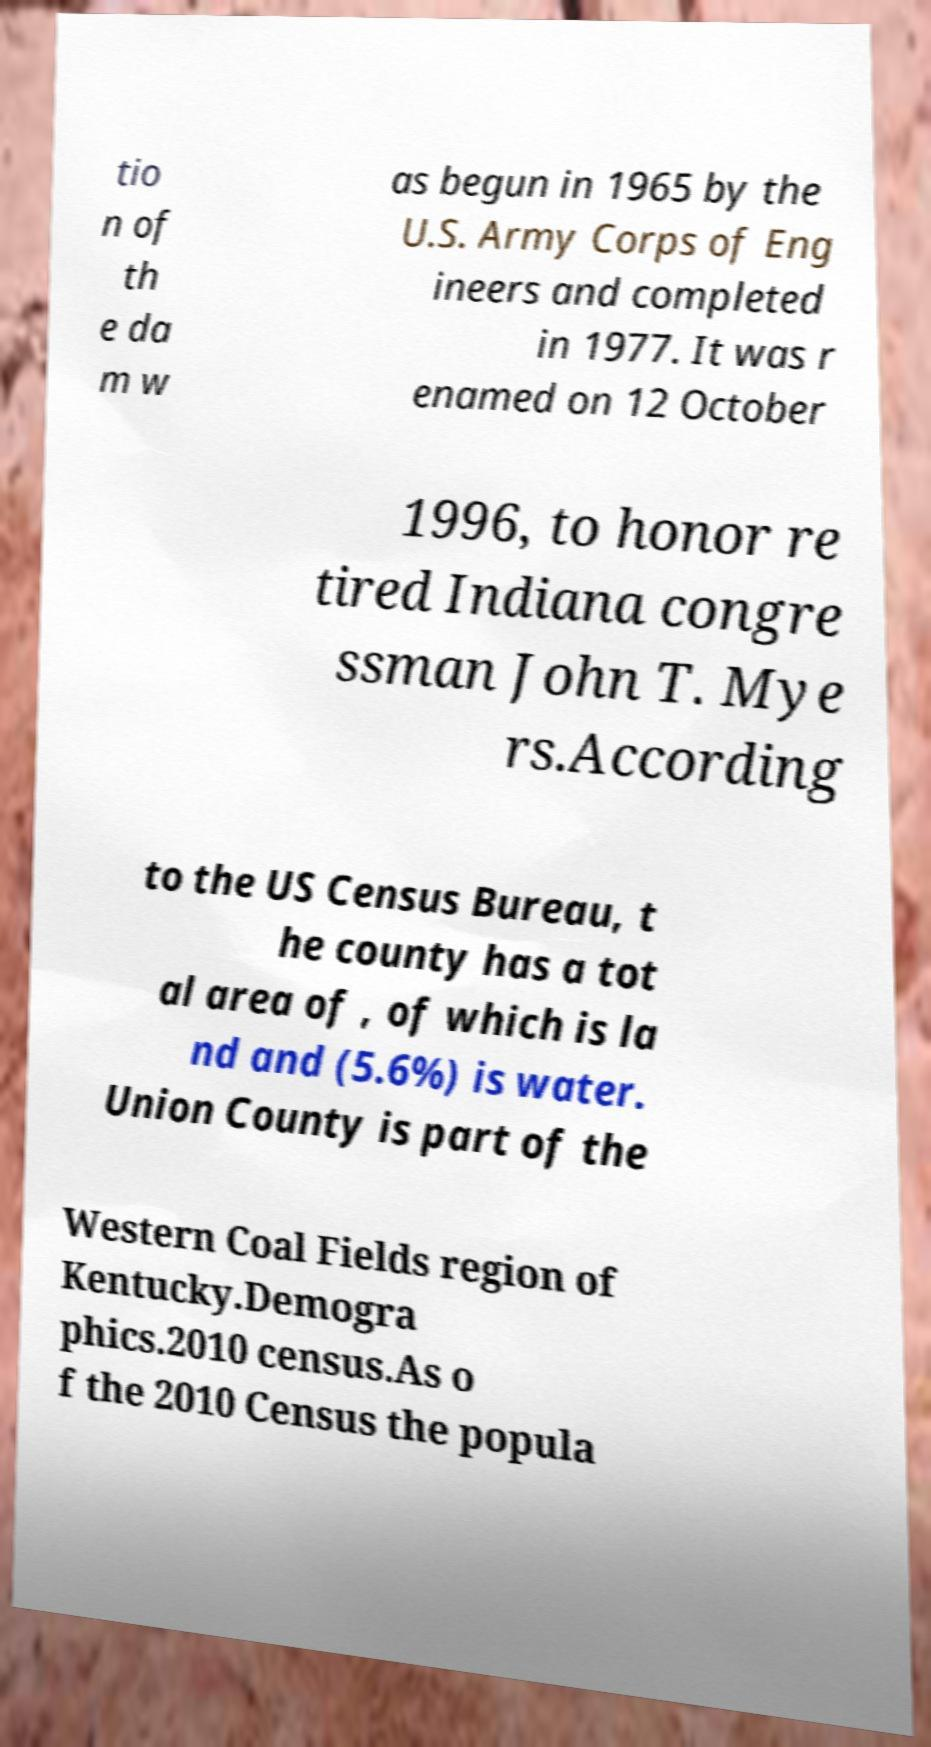Can you accurately transcribe the text from the provided image for me? tio n of th e da m w as begun in 1965 by the U.S. Army Corps of Eng ineers and completed in 1977. It was r enamed on 12 October 1996, to honor re tired Indiana congre ssman John T. Mye rs.According to the US Census Bureau, t he county has a tot al area of , of which is la nd and (5.6%) is water. Union County is part of the Western Coal Fields region of Kentucky.Demogra phics.2010 census.As o f the 2010 Census the popula 